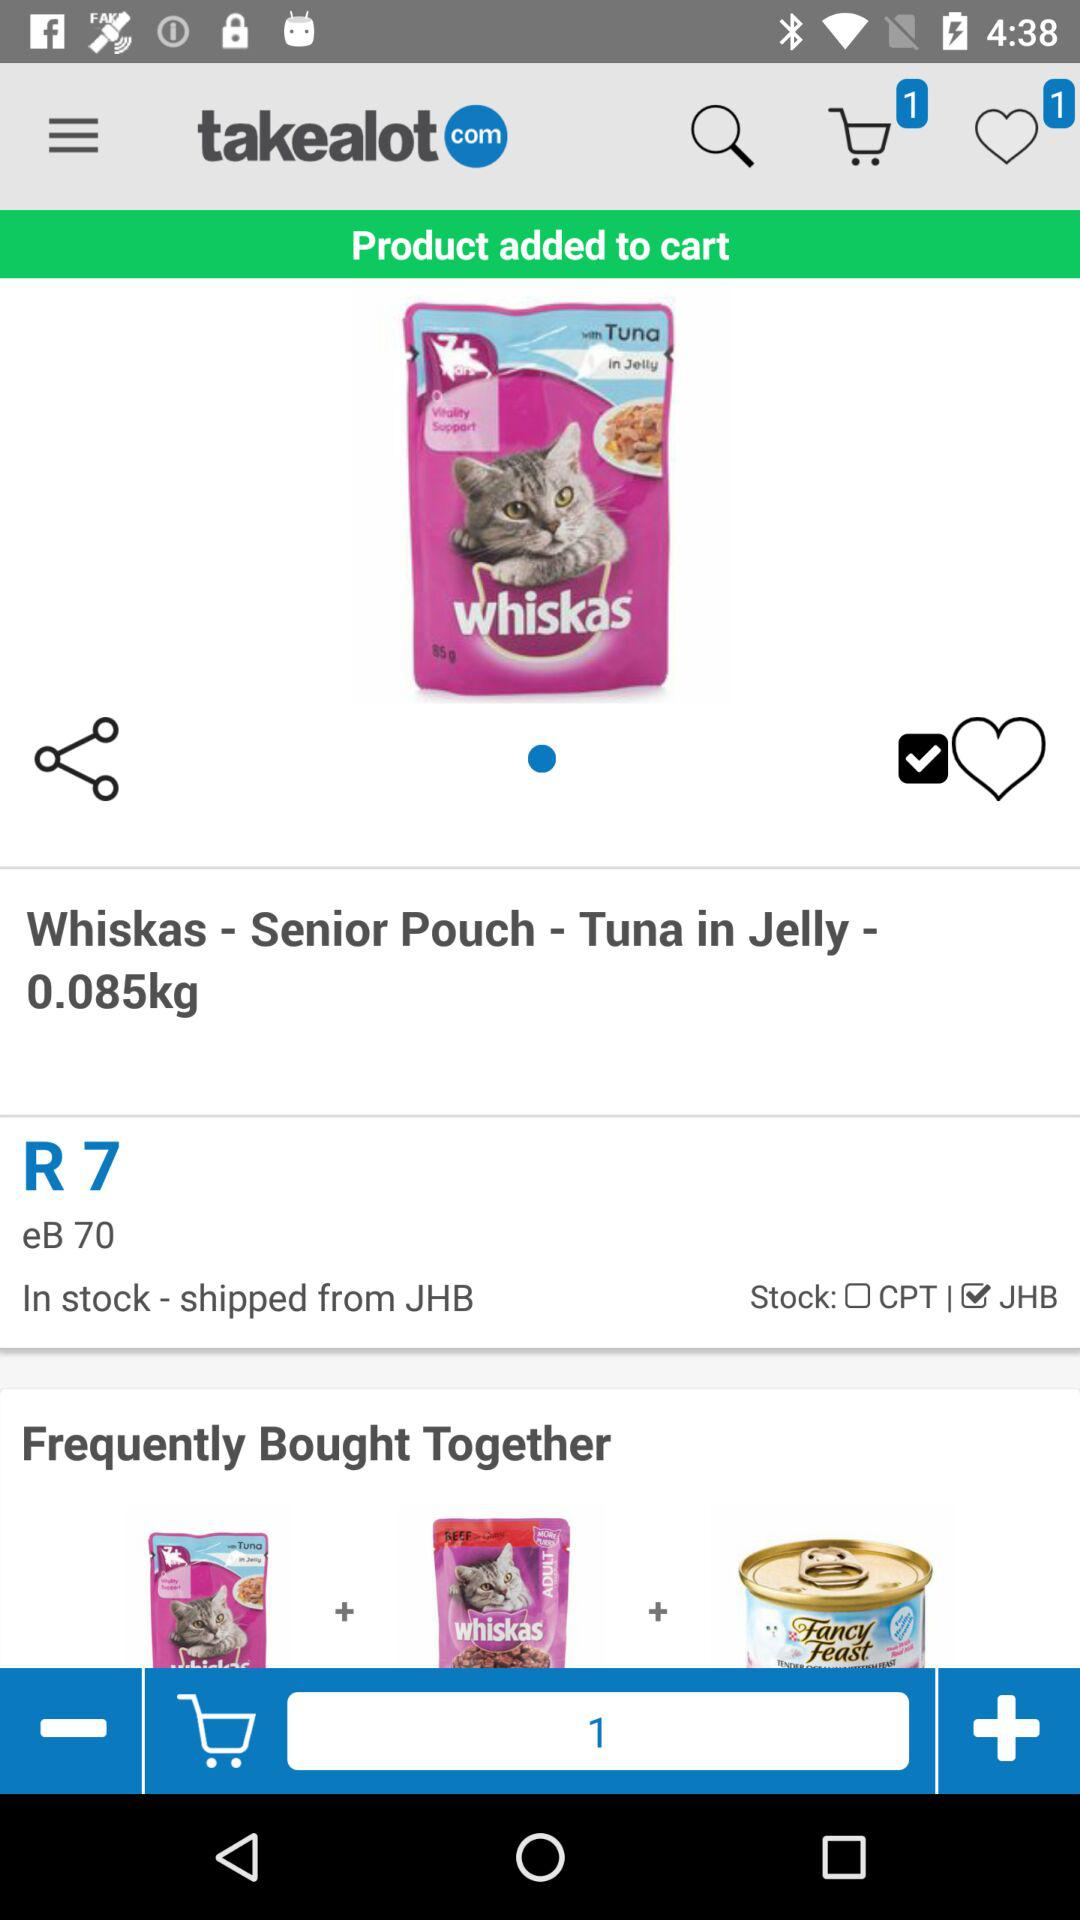How many items are in the shopping cart?
Answer the question using a single word or phrase. 1 